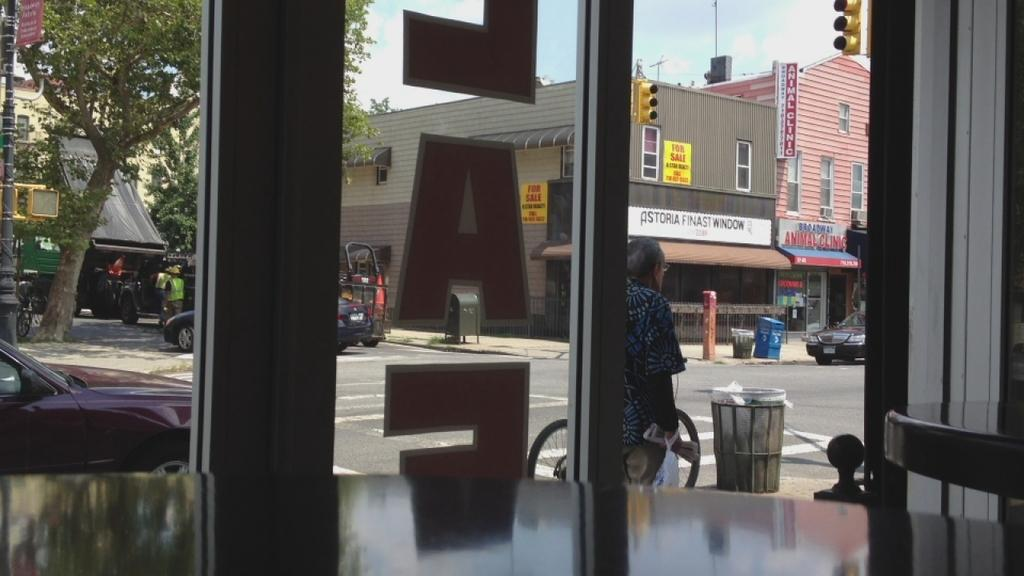What type of material is used for the windows in the image? There are glass windows in the image. What type of furniture can be seen in the image? There are tables in the image. What can be seen through the glass windows? Buildings, traffic lights, vehicles, trees, dustbins, boards, and the sky are visible through the glass windows. What type of cast can be seen on the person's arm in the image? There is no person or cast visible in the image. 